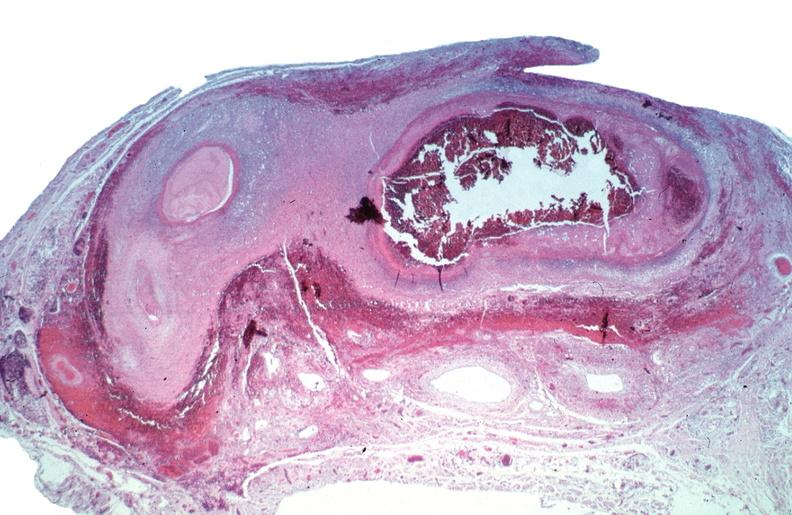what is present?
Answer the question using a single word or phrase. Vasculature 